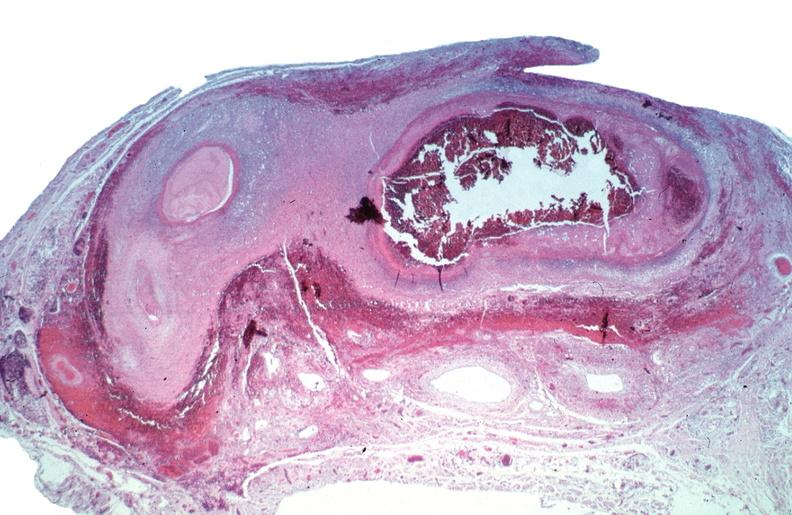what is present?
Answer the question using a single word or phrase. Vasculature 